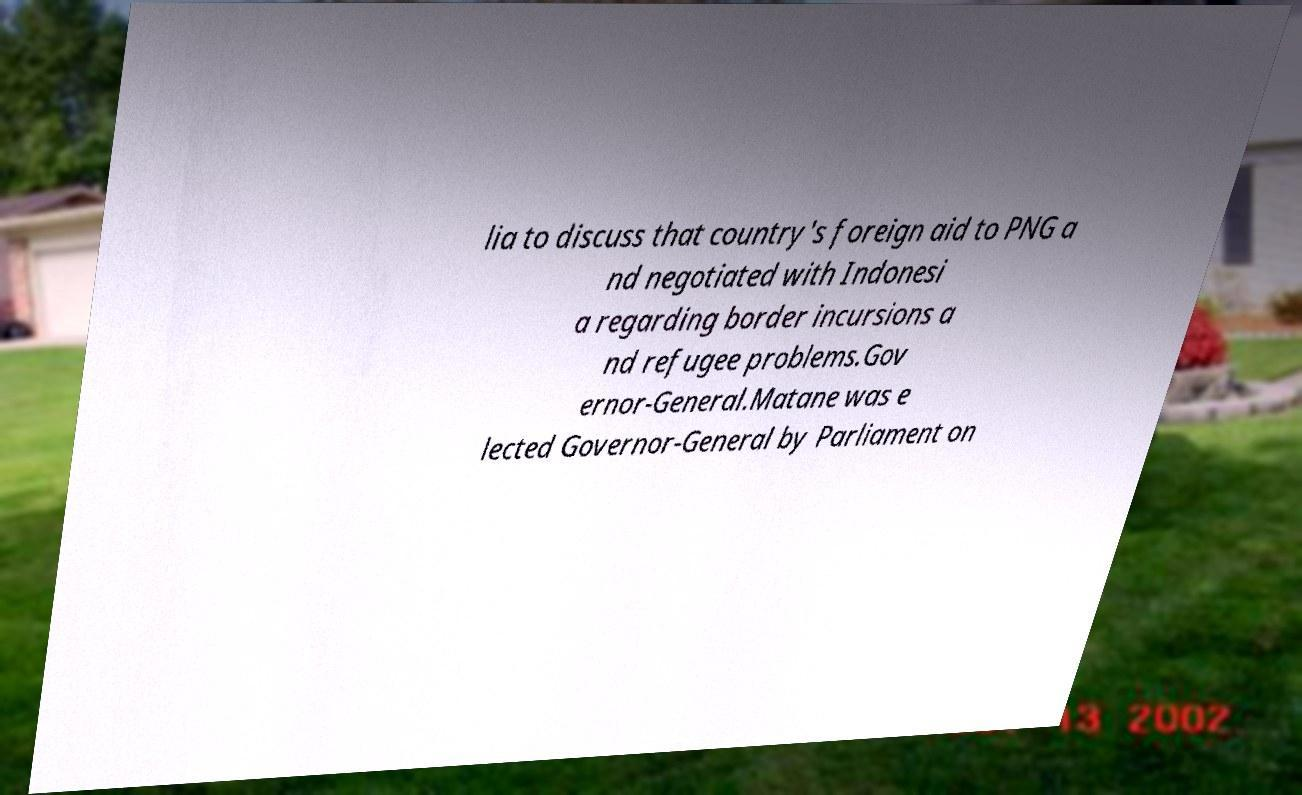There's text embedded in this image that I need extracted. Can you transcribe it verbatim? lia to discuss that country's foreign aid to PNG a nd negotiated with Indonesi a regarding border incursions a nd refugee problems.Gov ernor-General.Matane was e lected Governor-General by Parliament on 